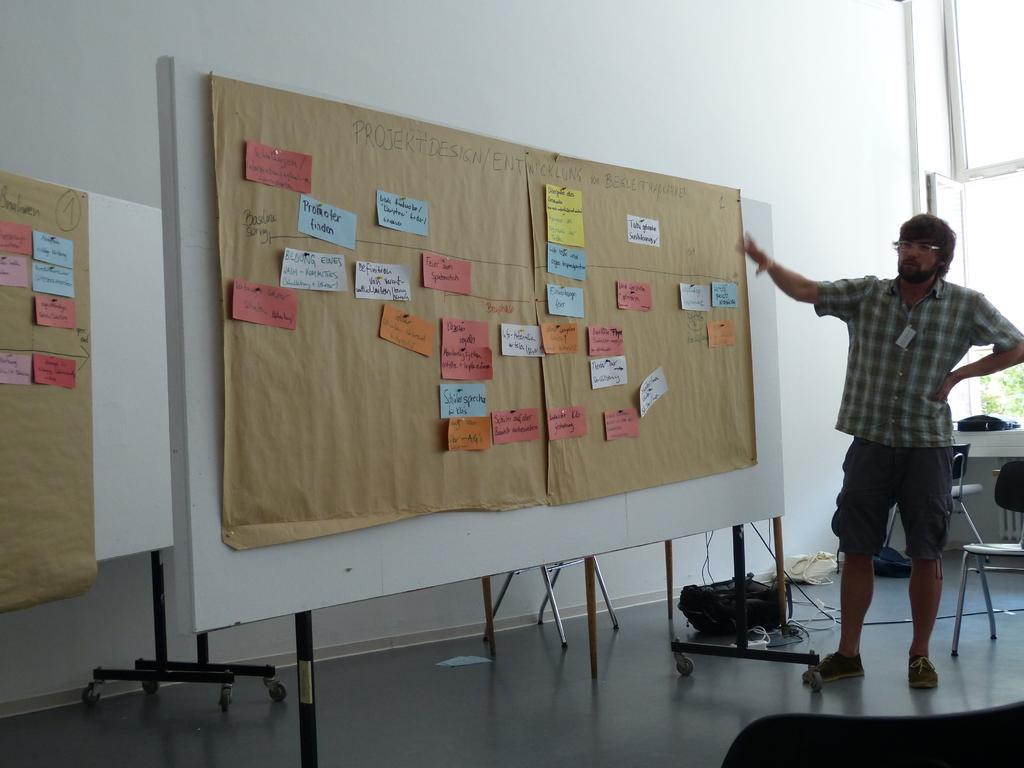What is the color of the wall in the image? The wall in the image is white. What can be seen on the wall in the image? There is a window on the wall in the image. What piece of furniture is present in the image? There is a chair in the image. What objects are on the chair in the image? There are papers on the chair in the image. Who is present in the image? There is a person standing in the image. How many icicles are hanging from the chair in the image? There are no icicles present in the image; it is an indoor setting with a chair and papers. What type of bed is visible in the image? There is no bed visible in the image; it only features a white wall, a window, a chair, papers, and a person standing. 